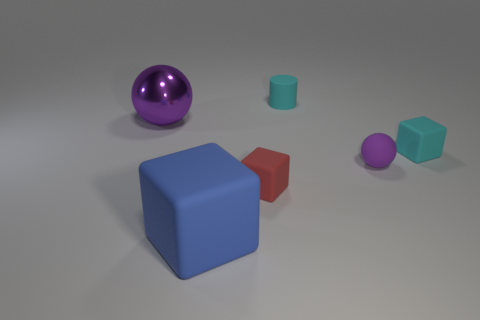Subtract all big cubes. How many cubes are left? 2 Subtract 1 red cubes. How many objects are left? 5 Subtract all balls. How many objects are left? 4 Subtract 1 cylinders. How many cylinders are left? 0 Subtract all green balls. Subtract all purple cylinders. How many balls are left? 2 Subtract all gray blocks. How many green balls are left? 0 Subtract all metallic things. Subtract all big blue rubber objects. How many objects are left? 4 Add 6 large metal balls. How many large metal balls are left? 7 Add 3 tiny rubber blocks. How many tiny rubber blocks exist? 5 Add 3 small rubber things. How many objects exist? 9 